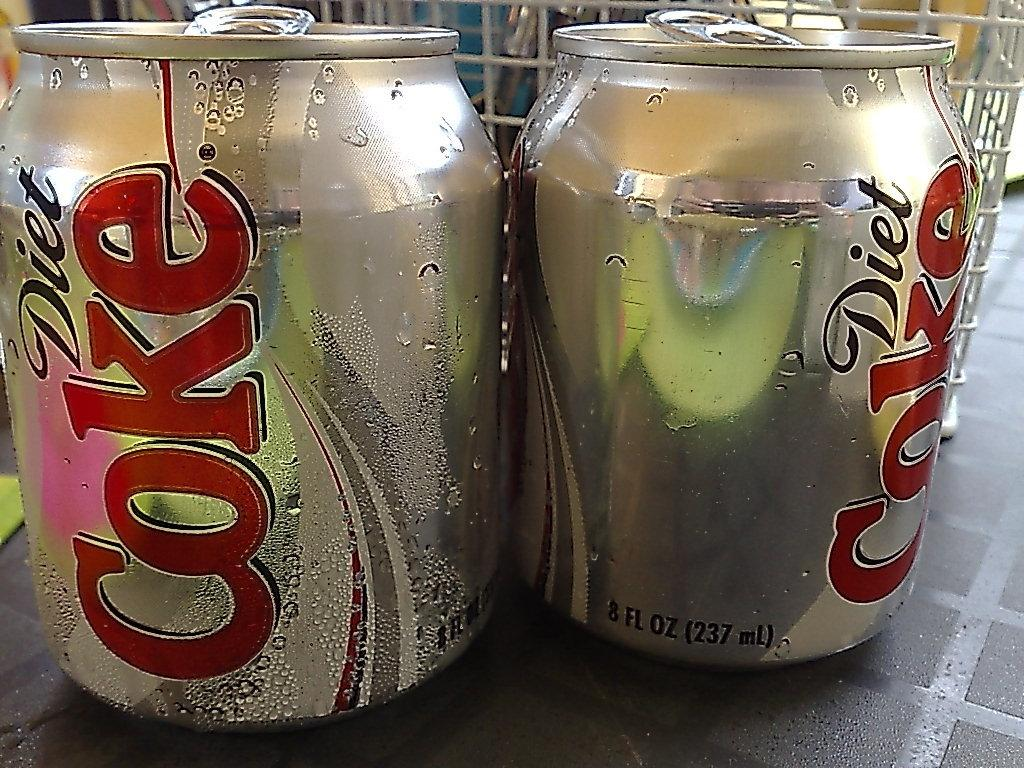What type of product is contained in the tins in the image? The tins in the image contain coke. What is the object that the coke tins are placed on? The coke tins are on an object, but the specific type of object is not mentioned in the facts. What can be seen behind the coke tins? There is a wire basket behind the coke tins. What does the caption on the coke tins say in the image? There is no mention of a caption on the coke tins in the provided facts, so we cannot determine what it says. 